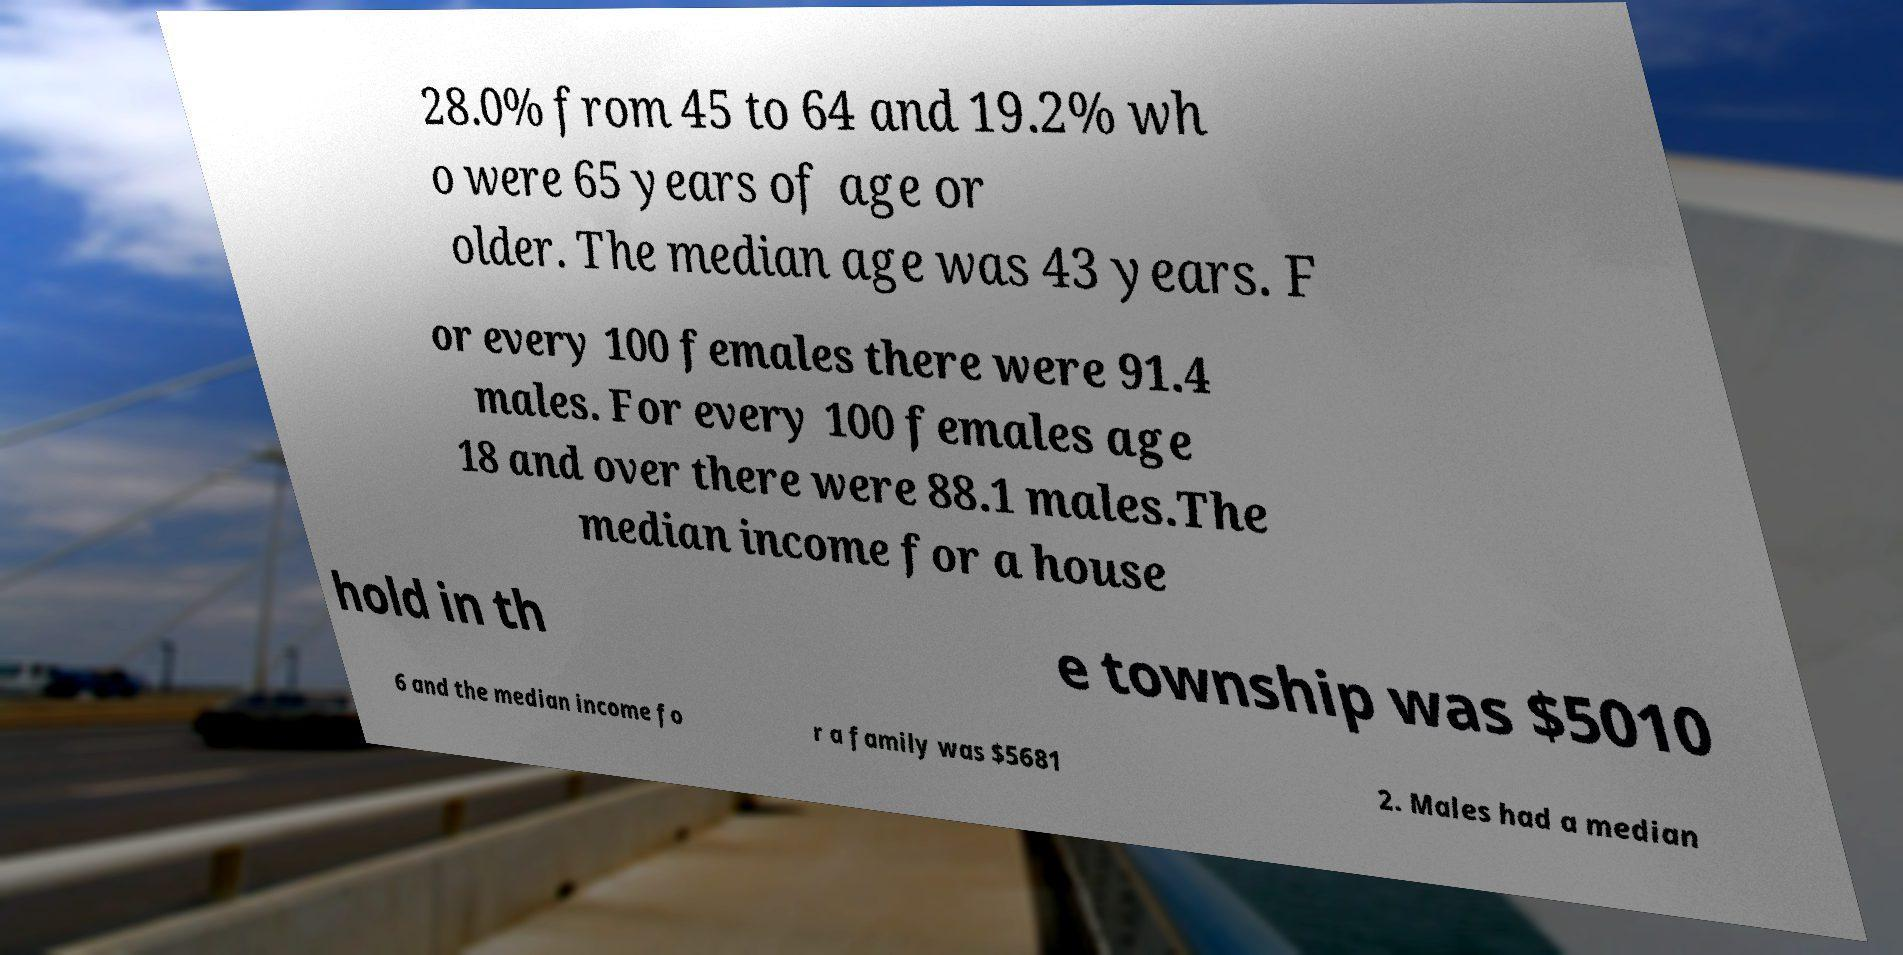For documentation purposes, I need the text within this image transcribed. Could you provide that? 28.0% from 45 to 64 and 19.2% wh o were 65 years of age or older. The median age was 43 years. F or every 100 females there were 91.4 males. For every 100 females age 18 and over there were 88.1 males.The median income for a house hold in th e township was $5010 6 and the median income fo r a family was $5681 2. Males had a median 